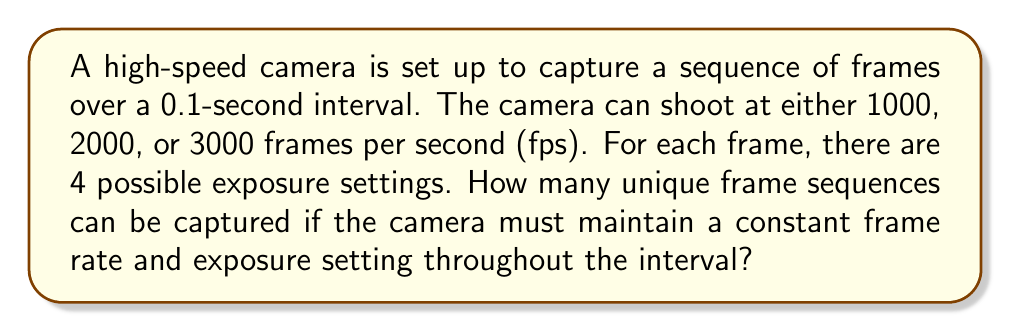Teach me how to tackle this problem. Let's approach this step-by-step:

1) First, we need to determine the number of frames for each possible frame rate:
   - At 1000 fps: $0.1 \text{ seconds} \times 1000 \text{ fps} = 100 \text{ frames}$
   - At 2000 fps: $0.1 \text{ seconds} \times 2000 \text{ fps} = 200 \text{ frames}$
   - At 3000 fps: $0.1 \text{ seconds} \times 3000 \text{ fps} = 300 \text{ frames}$

2) For each frame rate, we have 4 possible exposure settings.

3) The camera must maintain a constant frame rate and exposure setting throughout the interval. This means we're choosing one frame rate and one exposure setting for the entire sequence.

4) For each combination of frame rate and exposure setting, we have a unique sequence.

5) To calculate the total number of unique sequences:
   - We have 3 choices for frame rate
   - For each frame rate, we have 4 choices for exposure setting
   - Therefore, the total number of unique sequences is $3 \times 4 = 12$

6) We can express this mathematically as:

   $$\text{Total Sequences} = |\text{Frame Rates}| \times |\text{Exposure Settings}| = 3 \times 4 = 12$$

   Where $|\text{Set}|$ denotes the number of elements in the set.
Answer: 12 unique sequences 